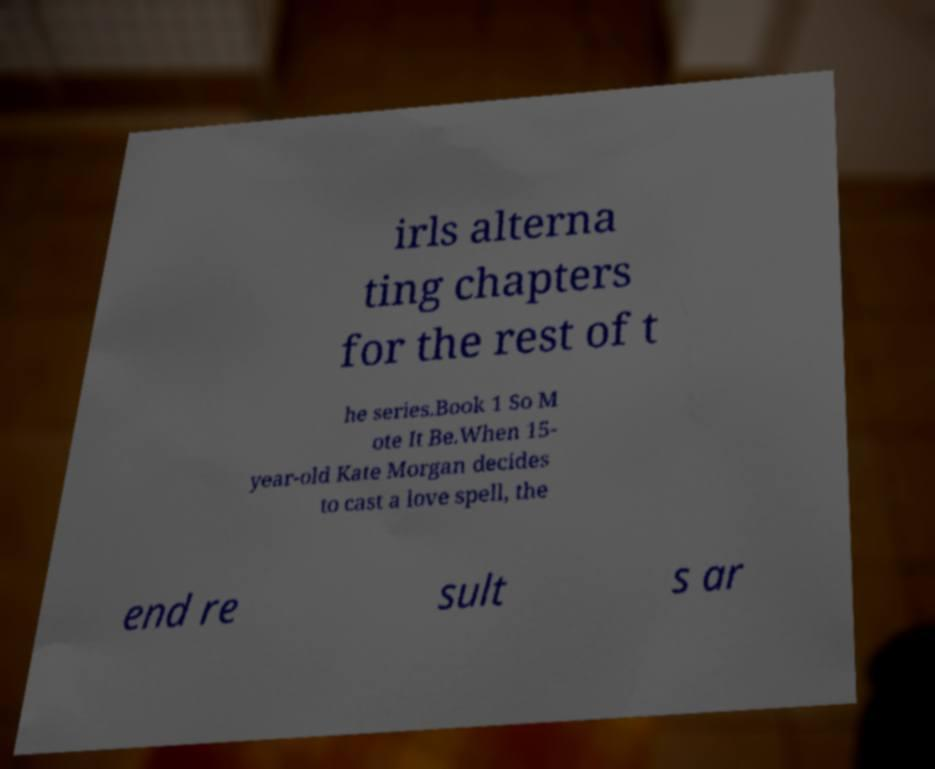What messages or text are displayed in this image? I need them in a readable, typed format. irls alterna ting chapters for the rest of t he series.Book 1 So M ote It Be.When 15- year-old Kate Morgan decides to cast a love spell, the end re sult s ar 